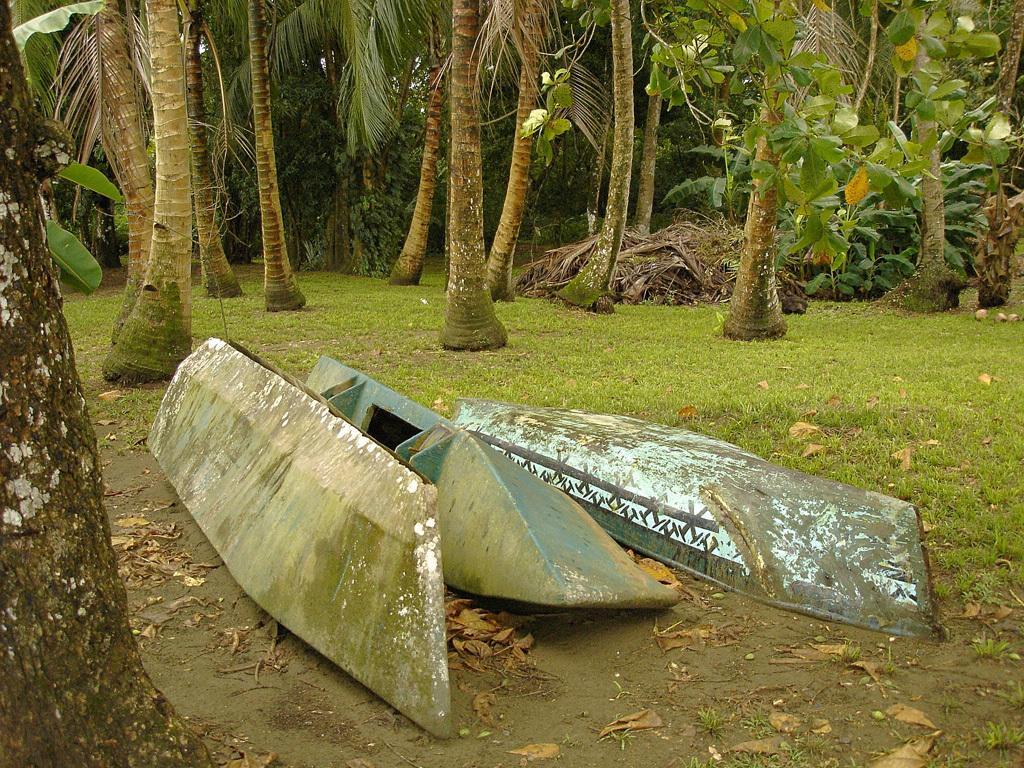In one or two sentences, can you explain what this image depicts? These are boats and green color trees. 